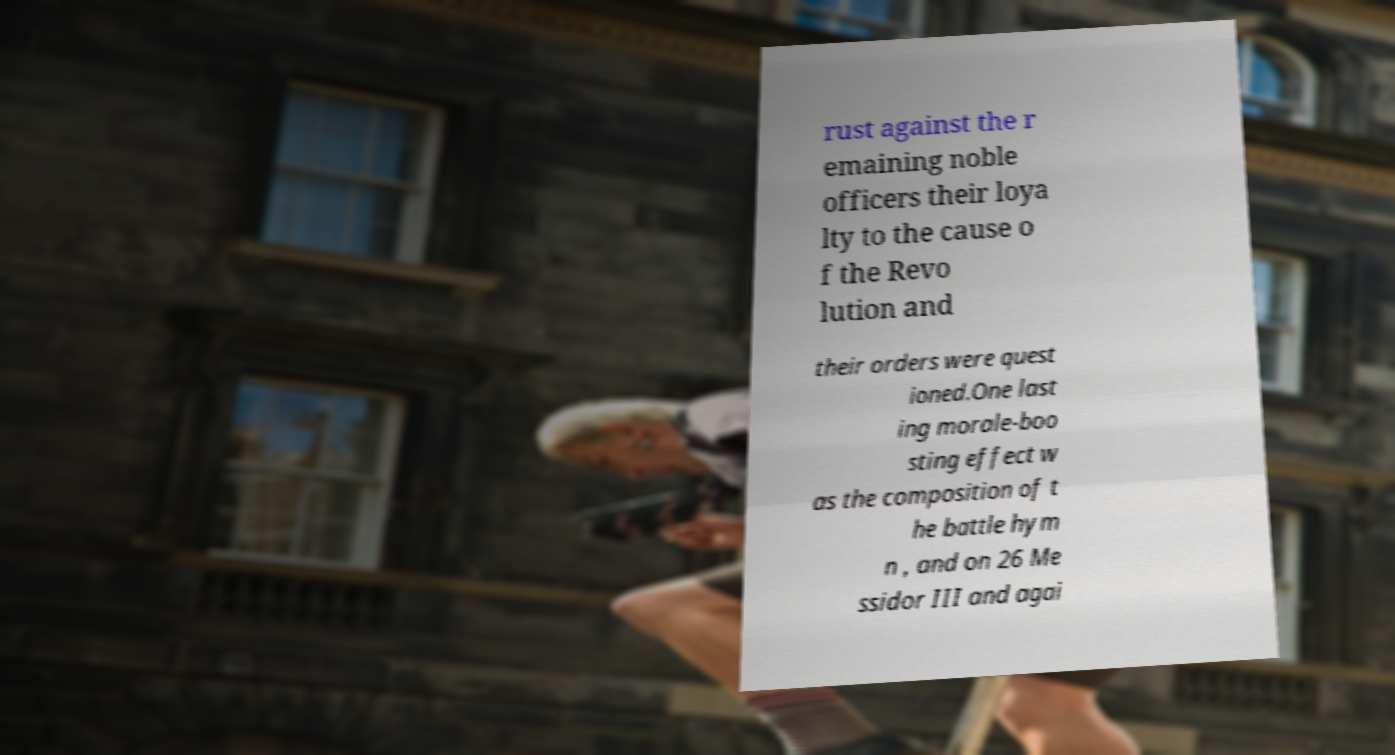What messages or text are displayed in this image? I need them in a readable, typed format. rust against the r emaining noble officers their loya lty to the cause o f the Revo lution and their orders were quest ioned.One last ing morale-boo sting effect w as the composition of t he battle hym n , and on 26 Me ssidor III and agai 